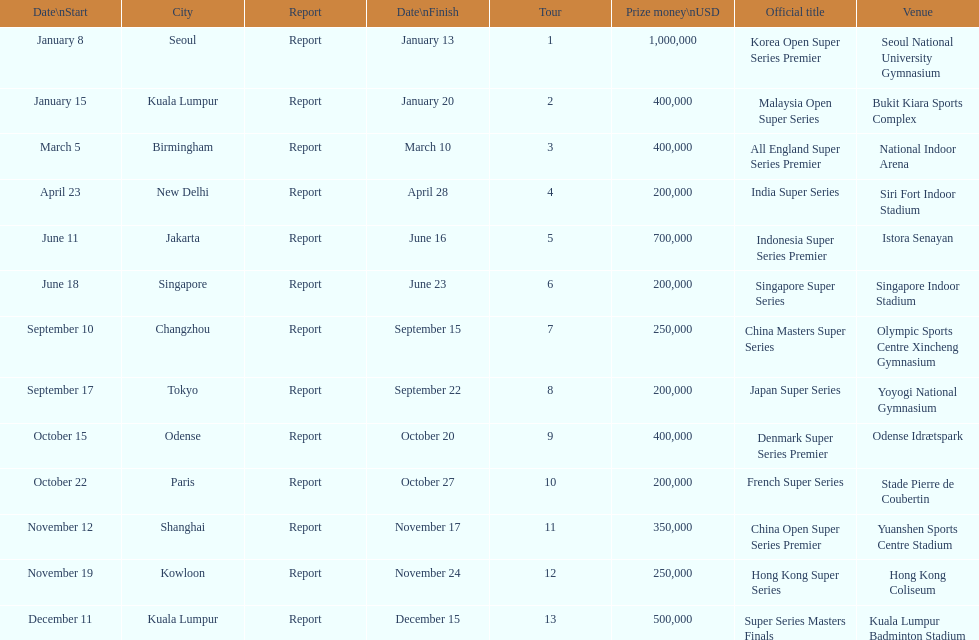Which series has the highest prize payout? Korea Open Super Series Premier. 